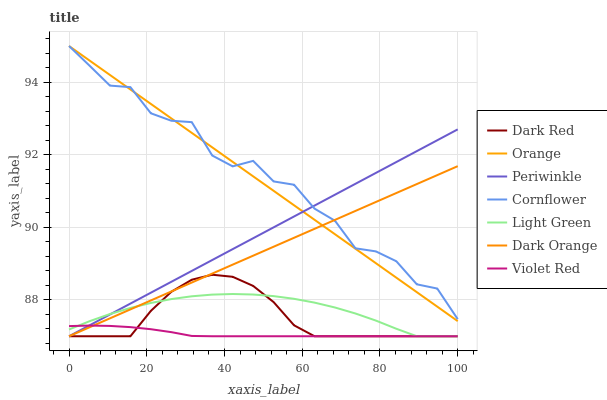Does Violet Red have the minimum area under the curve?
Answer yes or no. Yes. Does Cornflower have the maximum area under the curve?
Answer yes or no. Yes. Does Cornflower have the minimum area under the curve?
Answer yes or no. No. Does Violet Red have the maximum area under the curve?
Answer yes or no. No. Is Dark Orange the smoothest?
Answer yes or no. Yes. Is Cornflower the roughest?
Answer yes or no. Yes. Is Violet Red the smoothest?
Answer yes or no. No. Is Violet Red the roughest?
Answer yes or no. No. Does Cornflower have the lowest value?
Answer yes or no. No. Does Orange have the highest value?
Answer yes or no. Yes. Does Violet Red have the highest value?
Answer yes or no. No. Is Dark Red less than Cornflower?
Answer yes or no. Yes. Is Cornflower greater than Violet Red?
Answer yes or no. Yes. Does Violet Red intersect Dark Orange?
Answer yes or no. Yes. Is Violet Red less than Dark Orange?
Answer yes or no. No. Is Violet Red greater than Dark Orange?
Answer yes or no. No. Does Dark Red intersect Cornflower?
Answer yes or no. No. 